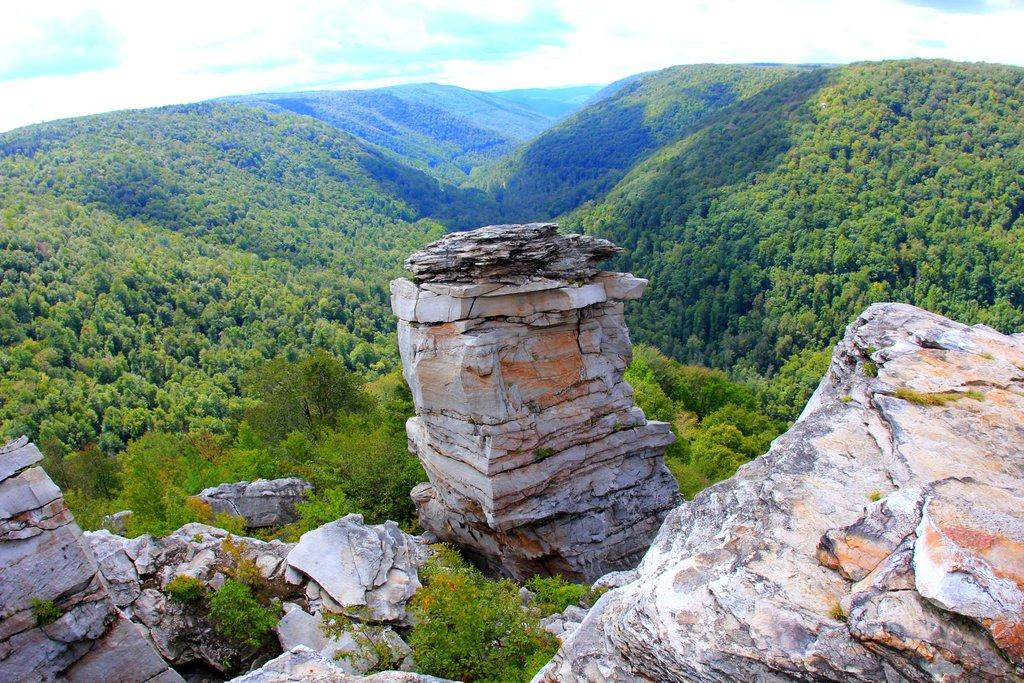What type of natural landscape is depicted in the image? The image features mountains, trees, and rocks, which are all elements of a natural landscape. Can you describe the sky in the image? The sky is visible in the image. What type of vegetation can be seen in the image? There are trees in the image. How many chairs are placed around the cup in the image? There are no chairs or cups present in the image. What type of experience can be gained from the mountains in the image? The image does not convey any specific experience; it simply depicts mountains, trees, and rocks. 